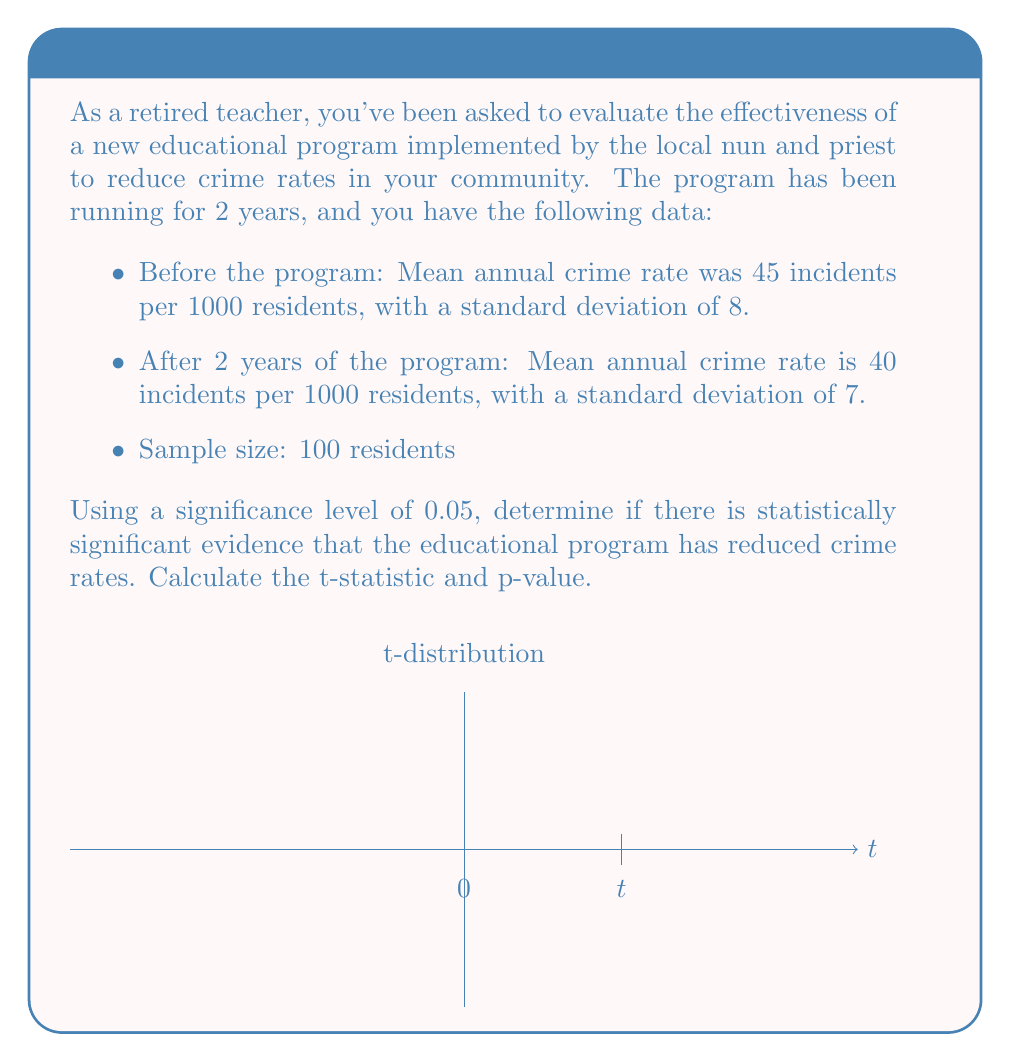Solve this math problem. Let's approach this step-by-step:

1) First, we need to formulate our null and alternative hypotheses:
   $H_0: \mu_1 - \mu_2 = 0$ (no difference in crime rates)
   $H_a: \mu_1 - \mu_2 > 0$ (crime rate has decreased)

2) We'll use a paired t-test. The formula for the t-statistic is:

   $$t = \frac{\bar{x}_1 - \bar{x}_2}{\sqrt{\frac{s_1^2}{n_1} + \frac{s_2^2}{n_2}}}$$

   Where:
   $\bar{x}_1 = 45$ (mean before)
   $\bar{x}_2 = 40$ (mean after)
   $s_1 = 8$ (std dev before)
   $s_2 = 7$ (std dev after)
   $n_1 = n_2 = 100$ (sample size)

3) Plugging in the values:

   $$t = \frac{45 - 40}{\sqrt{\frac{8^2}{100} + \frac{7^2}{100}}} = \frac{5}{\sqrt{0.64 + 0.49}} = \frac{5}{\sqrt{1.13}} = \frac{5}{1.0630} = 4.7037$$

4) The degrees of freedom for this test is:
   $df = n_1 + n_2 - 2 = 100 + 100 - 2 = 198$

5) For a one-tailed test with $\alpha = 0.05$ and $df = 198$, the critical t-value is approximately 1.653.

6) Since our calculated t-value (4.7037) is greater than the critical t-value (1.653), we reject the null hypothesis.

7) To calculate the p-value, we can use a t-distribution calculator or table. The p-value for t = 4.7037 with df = 198 is p < 0.0001.
Answer: t-statistic = 4.7037, p-value < 0.0001. Statistically significant evidence of crime rate reduction. 